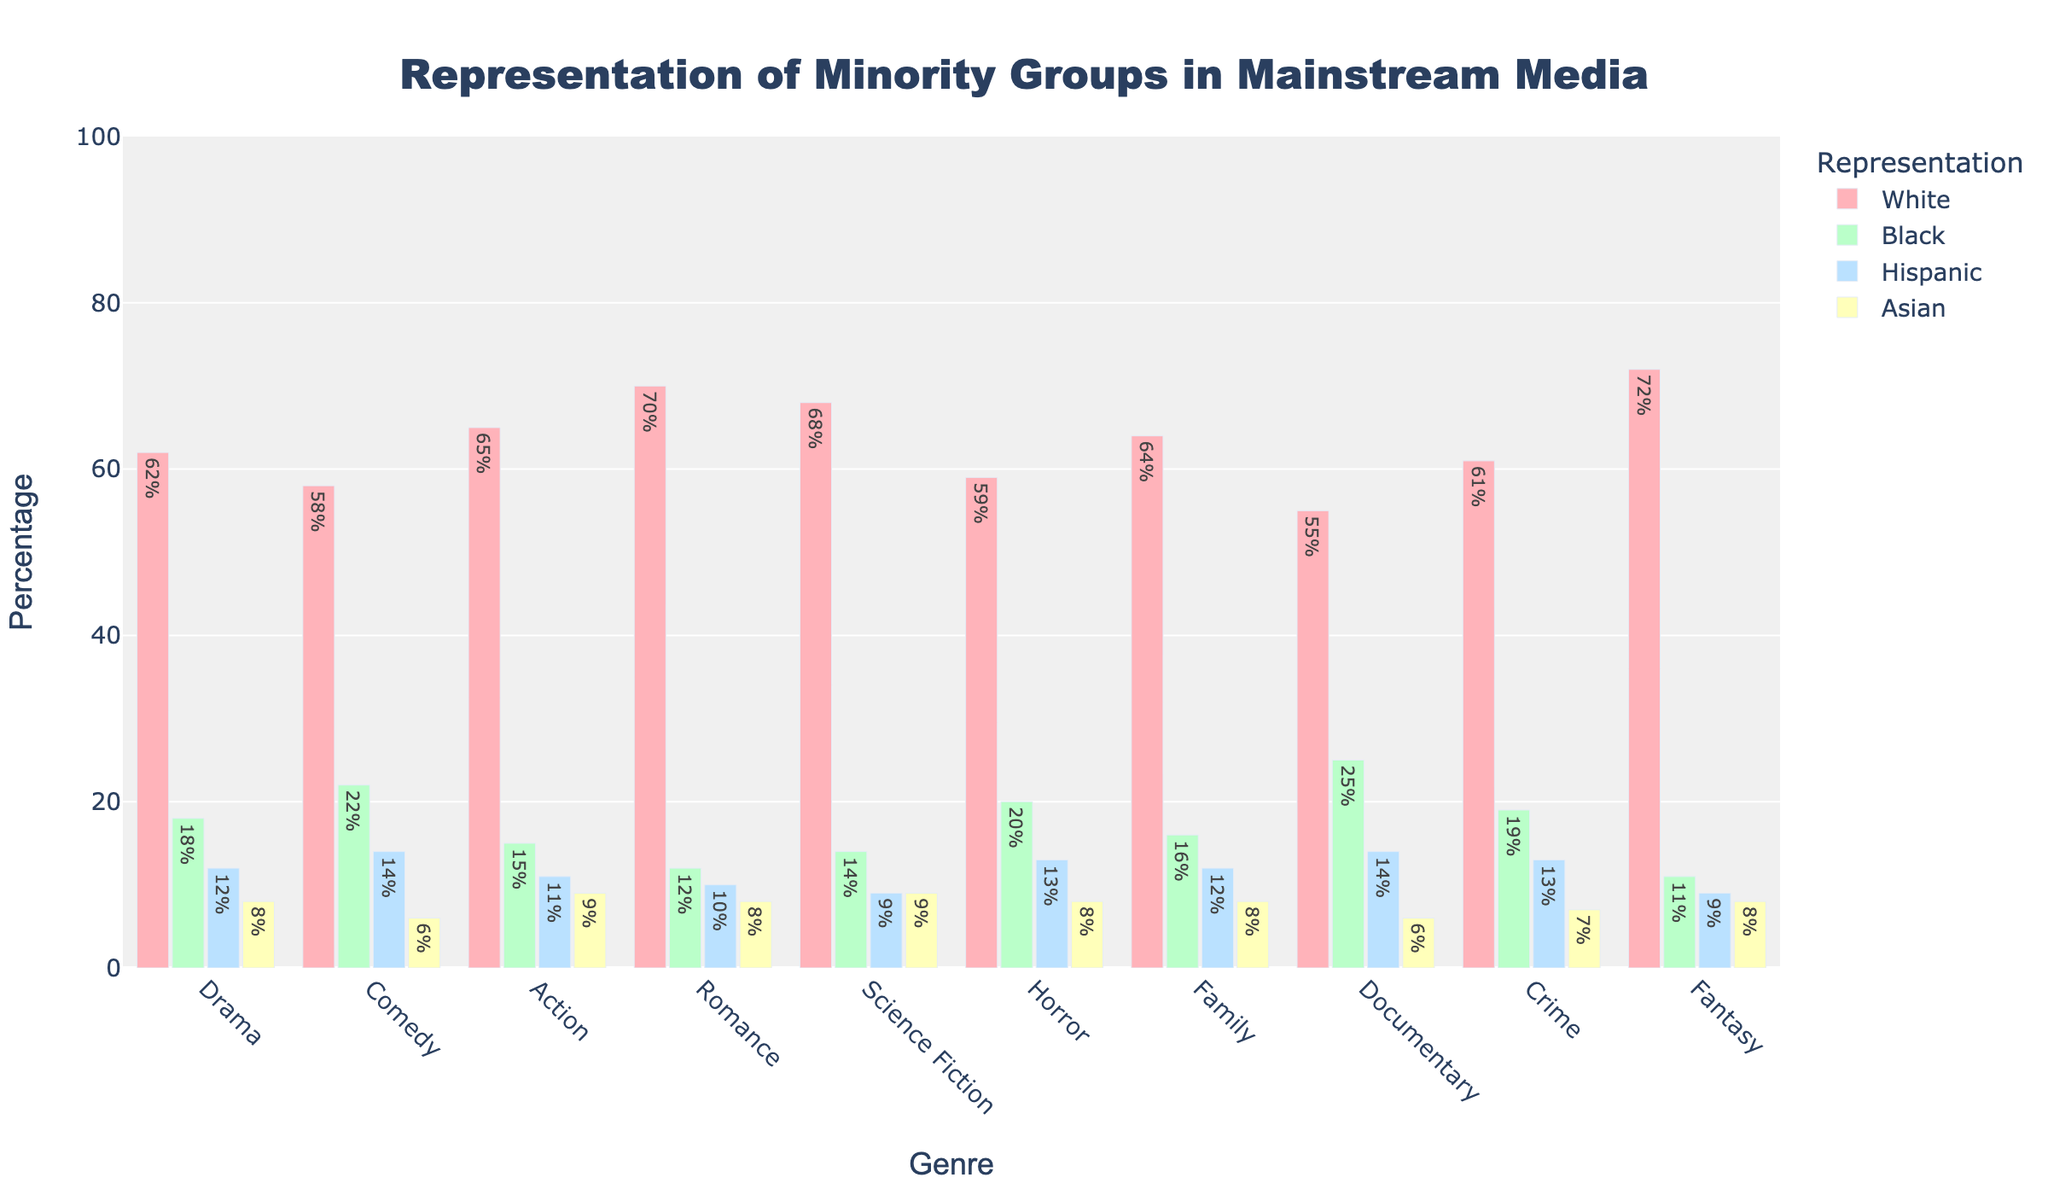Which genre has the highest white representation? The bar representing the Romance genre is the tallest among the white representation bars, indicating the highest percentage.
Answer: Romance Which genre has the lowest Hispanic representation? The Fantasy genre has the shortest bar for Hispanic representation.
Answer: Fantasy In which genre is black representation the highest? The Documentary genre’s bar for black representation is the highest.
Answer: Documentary Is there a genre where Asian representation is higher than Hispanic representation? All genres show a higher percentage for Hispanic representation than Asian representation based on the bar heights.
Answer: No What is the difference between white representation in Action and Drama genres? The white representation percentage for Action is 65%, and for Drama, it is 62%. The absolute difference is 65 - 62 = 3.
Answer: 3 Compare the black representation percentages in Comedy and Horror genres. Which is higher? The bar for Comedy has a black representation of 22%, while Horror has 20%. Comedy’s representation is higher than Horror’s.
Answer: Comedy What is the range of white representation percentages across all genres? The highest white representation is in Fantasy at 72%, and the lowest is in Documentary at 55%. The range is 72 - 55 = 17.
Answer: 17 Which genre has exactly equal representation percentages for Asian and Hispanic groups? Both Science Fiction and Fantasy genres show their bars for Asian and Hispanic representation at the same height (9%).
Answer: Science Fiction, Fantasy Sum the black representation percentages across Documentary and Horror genres. Documentary has a black representation of 25%, and Horror has 20%. The sum is 25 + 20 = 45.
Answer: 45 